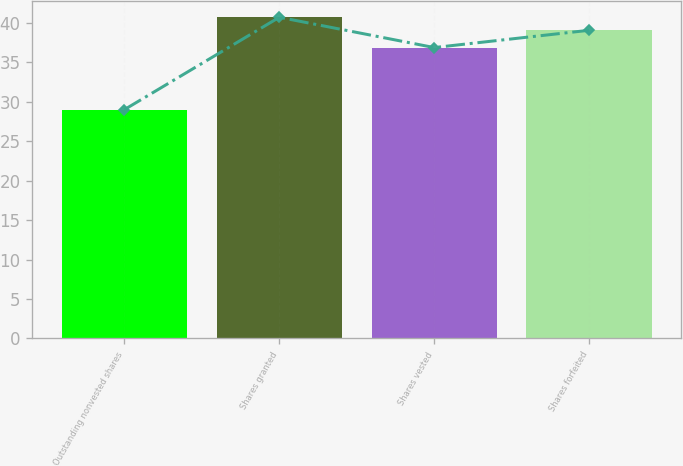Convert chart to OTSL. <chart><loc_0><loc_0><loc_500><loc_500><bar_chart><fcel>Outstanding nonvested shares<fcel>Shares granted<fcel>Shares vested<fcel>Shares forfeited<nl><fcel>29.02<fcel>40.72<fcel>36.88<fcel>39.07<nl></chart> 